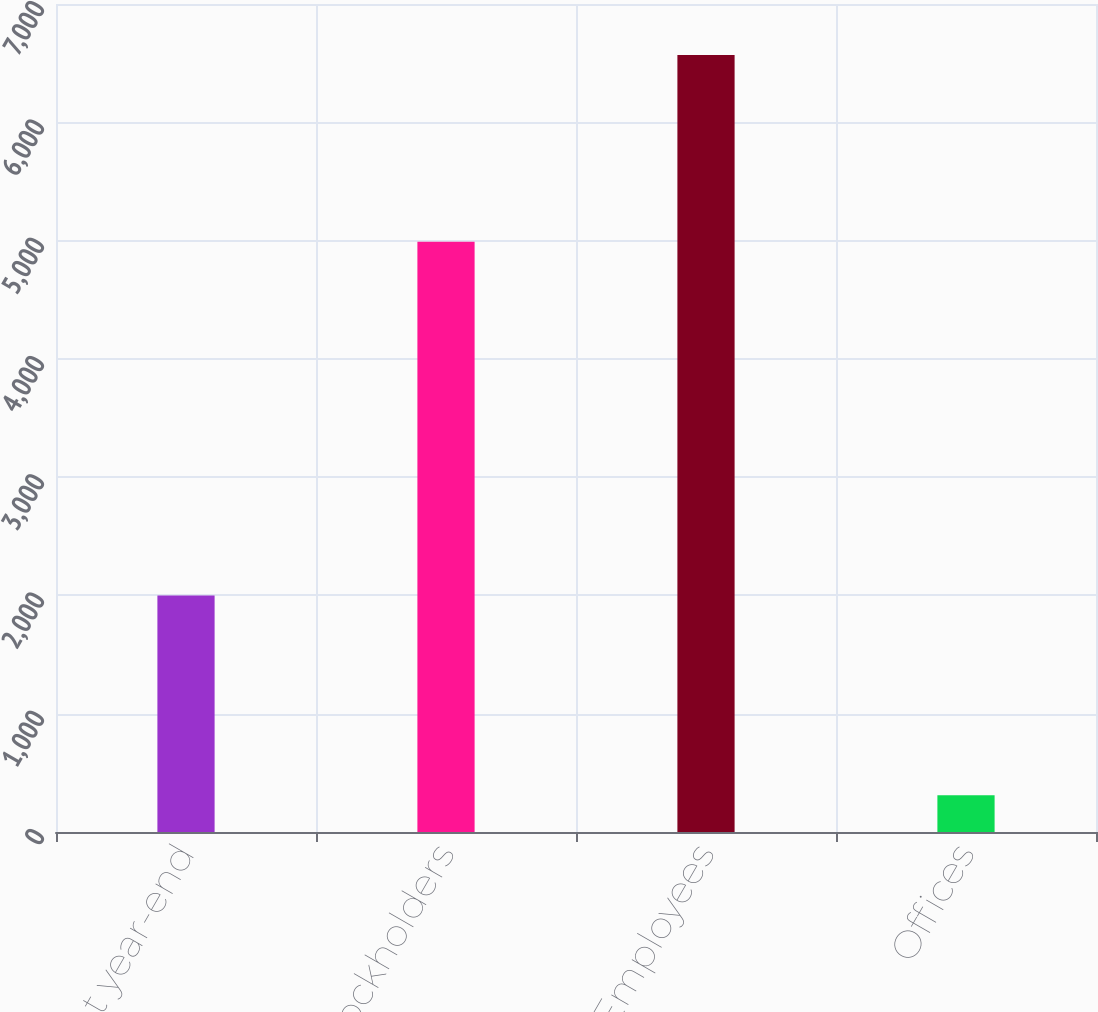Convert chart. <chart><loc_0><loc_0><loc_500><loc_500><bar_chart><fcel>Number at year-end<fcel>Stockholders<fcel>Employees<fcel>Offices<nl><fcel>1999<fcel>4991<fcel>6569<fcel>310<nl></chart> 